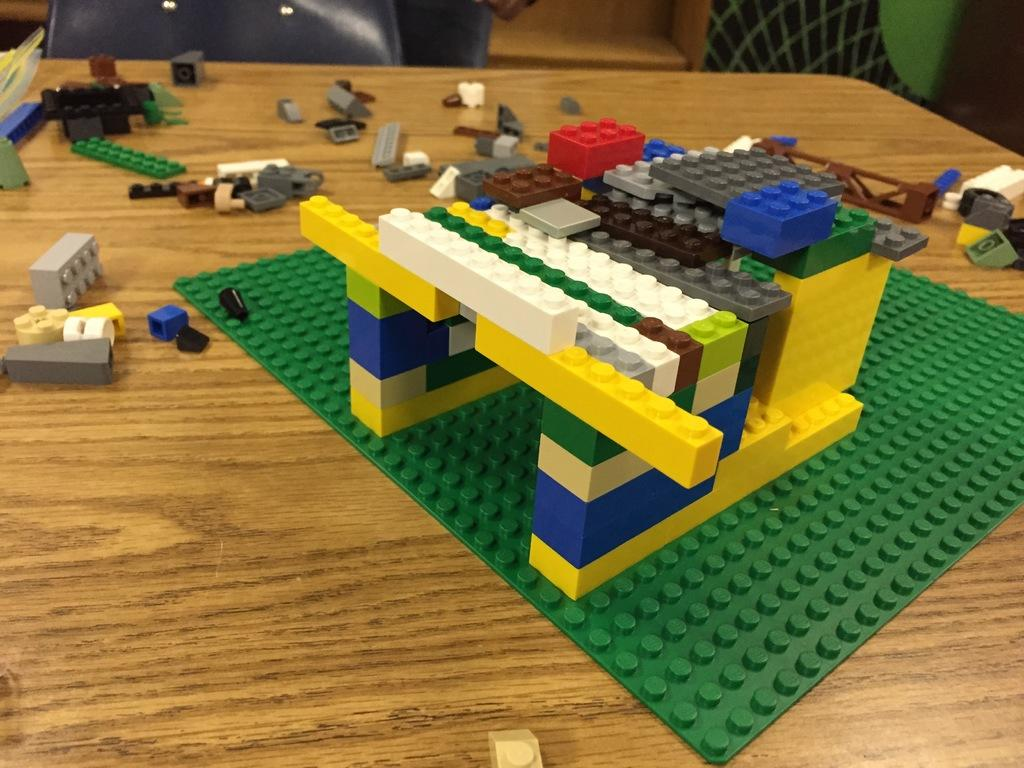What objects are present in the image? There are toys in the image. What type of surface are the toys placed on? The toys are placed on a wooden surface. Can you see a ghost interacting with the toys in the image? There is no ghost present in the image; it only features toys placed on a wooden surface. 